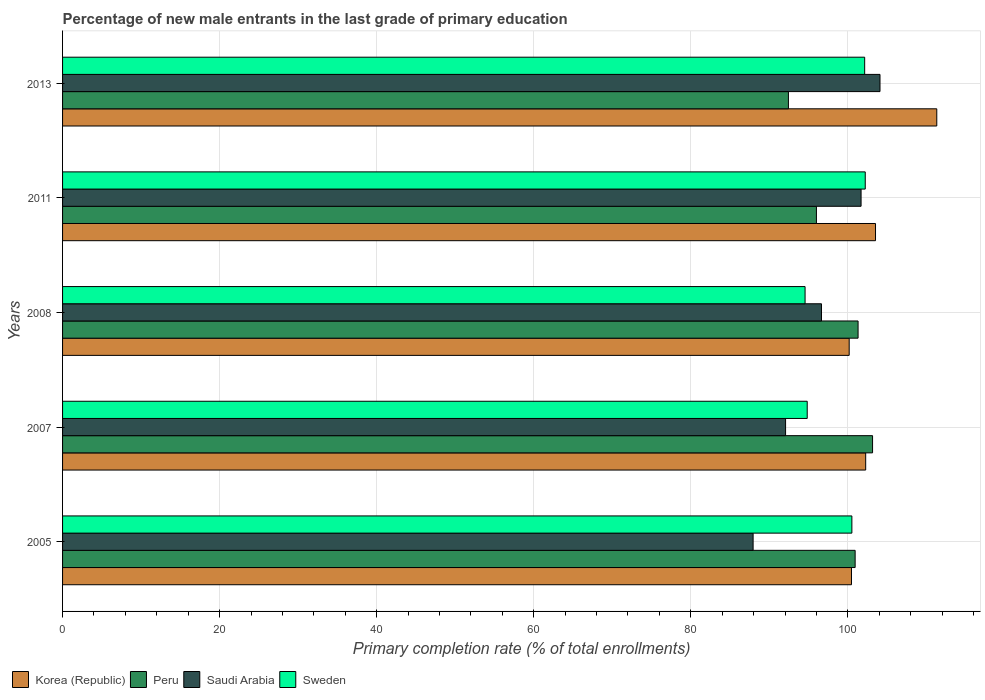How many groups of bars are there?
Provide a short and direct response. 5. Are the number of bars per tick equal to the number of legend labels?
Offer a terse response. Yes. Are the number of bars on each tick of the Y-axis equal?
Offer a terse response. Yes. How many bars are there on the 2nd tick from the bottom?
Offer a very short reply. 4. In how many cases, is the number of bars for a given year not equal to the number of legend labels?
Provide a short and direct response. 0. What is the percentage of new male entrants in Korea (Republic) in 2005?
Offer a very short reply. 100.47. Across all years, what is the maximum percentage of new male entrants in Saudi Arabia?
Provide a short and direct response. 104.1. Across all years, what is the minimum percentage of new male entrants in Korea (Republic)?
Your answer should be very brief. 100.17. In which year was the percentage of new male entrants in Sweden maximum?
Offer a terse response. 2011. What is the total percentage of new male entrants in Peru in the graph?
Ensure brevity in your answer.  493.83. What is the difference between the percentage of new male entrants in Sweden in 2008 and that in 2011?
Your answer should be compact. -7.66. What is the difference between the percentage of new male entrants in Korea (Republic) in 2011 and the percentage of new male entrants in Peru in 2008?
Provide a succinct answer. 2.22. What is the average percentage of new male entrants in Korea (Republic) per year?
Give a very brief answer. 103.55. In the year 2013, what is the difference between the percentage of new male entrants in Sweden and percentage of new male entrants in Korea (Republic)?
Ensure brevity in your answer.  -9.18. What is the ratio of the percentage of new male entrants in Saudi Arabia in 2005 to that in 2008?
Provide a succinct answer. 0.91. Is the percentage of new male entrants in Peru in 2007 less than that in 2013?
Your answer should be very brief. No. Is the difference between the percentage of new male entrants in Sweden in 2007 and 2008 greater than the difference between the percentage of new male entrants in Korea (Republic) in 2007 and 2008?
Keep it short and to the point. No. What is the difference between the highest and the second highest percentage of new male entrants in Saudi Arabia?
Make the answer very short. 2.41. What is the difference between the highest and the lowest percentage of new male entrants in Saudi Arabia?
Provide a succinct answer. 16.16. In how many years, is the percentage of new male entrants in Korea (Republic) greater than the average percentage of new male entrants in Korea (Republic) taken over all years?
Provide a succinct answer. 1. Is it the case that in every year, the sum of the percentage of new male entrants in Sweden and percentage of new male entrants in Saudi Arabia is greater than the sum of percentage of new male entrants in Korea (Republic) and percentage of new male entrants in Peru?
Provide a short and direct response. No. What does the 2nd bar from the top in 2011 represents?
Give a very brief answer. Saudi Arabia. What does the 2nd bar from the bottom in 2013 represents?
Your answer should be very brief. Peru. Is it the case that in every year, the sum of the percentage of new male entrants in Sweden and percentage of new male entrants in Korea (Republic) is greater than the percentage of new male entrants in Saudi Arabia?
Provide a succinct answer. Yes. Are the values on the major ticks of X-axis written in scientific E-notation?
Give a very brief answer. No. Does the graph contain grids?
Offer a terse response. Yes. Where does the legend appear in the graph?
Make the answer very short. Bottom left. How many legend labels are there?
Keep it short and to the point. 4. What is the title of the graph?
Keep it short and to the point. Percentage of new male entrants in the last grade of primary education. What is the label or title of the X-axis?
Give a very brief answer. Primary completion rate (% of total enrollments). What is the Primary completion rate (% of total enrollments) of Korea (Republic) in 2005?
Your response must be concise. 100.47. What is the Primary completion rate (% of total enrollments) in Peru in 2005?
Ensure brevity in your answer.  100.93. What is the Primary completion rate (% of total enrollments) of Saudi Arabia in 2005?
Your response must be concise. 87.94. What is the Primary completion rate (% of total enrollments) of Sweden in 2005?
Provide a short and direct response. 100.52. What is the Primary completion rate (% of total enrollments) in Korea (Republic) in 2007?
Offer a terse response. 102.28. What is the Primary completion rate (% of total enrollments) in Peru in 2007?
Make the answer very short. 103.15. What is the Primary completion rate (% of total enrollments) of Saudi Arabia in 2007?
Give a very brief answer. 92.07. What is the Primary completion rate (% of total enrollments) of Sweden in 2007?
Your answer should be compact. 94.83. What is the Primary completion rate (% of total enrollments) of Korea (Republic) in 2008?
Give a very brief answer. 100.17. What is the Primary completion rate (% of total enrollments) in Peru in 2008?
Your response must be concise. 101.31. What is the Primary completion rate (% of total enrollments) in Saudi Arabia in 2008?
Offer a very short reply. 96.65. What is the Primary completion rate (% of total enrollments) of Sweden in 2008?
Make the answer very short. 94.56. What is the Primary completion rate (% of total enrollments) of Korea (Republic) in 2011?
Your answer should be compact. 103.53. What is the Primary completion rate (% of total enrollments) in Peru in 2011?
Offer a very short reply. 96. What is the Primary completion rate (% of total enrollments) in Saudi Arabia in 2011?
Provide a succinct answer. 101.69. What is the Primary completion rate (% of total enrollments) in Sweden in 2011?
Provide a short and direct response. 102.22. What is the Primary completion rate (% of total enrollments) in Korea (Republic) in 2013?
Your answer should be very brief. 111.33. What is the Primary completion rate (% of total enrollments) of Peru in 2013?
Keep it short and to the point. 92.44. What is the Primary completion rate (% of total enrollments) of Saudi Arabia in 2013?
Your answer should be very brief. 104.1. What is the Primary completion rate (% of total enrollments) in Sweden in 2013?
Your answer should be compact. 102.15. Across all years, what is the maximum Primary completion rate (% of total enrollments) of Korea (Republic)?
Give a very brief answer. 111.33. Across all years, what is the maximum Primary completion rate (% of total enrollments) of Peru?
Provide a succinct answer. 103.15. Across all years, what is the maximum Primary completion rate (% of total enrollments) of Saudi Arabia?
Offer a very short reply. 104.1. Across all years, what is the maximum Primary completion rate (% of total enrollments) of Sweden?
Provide a succinct answer. 102.22. Across all years, what is the minimum Primary completion rate (% of total enrollments) of Korea (Republic)?
Provide a succinct answer. 100.17. Across all years, what is the minimum Primary completion rate (% of total enrollments) of Peru?
Your response must be concise. 92.44. Across all years, what is the minimum Primary completion rate (% of total enrollments) in Saudi Arabia?
Your answer should be very brief. 87.94. Across all years, what is the minimum Primary completion rate (% of total enrollments) of Sweden?
Provide a succinct answer. 94.56. What is the total Primary completion rate (% of total enrollments) of Korea (Republic) in the graph?
Offer a very short reply. 517.77. What is the total Primary completion rate (% of total enrollments) in Peru in the graph?
Offer a terse response. 493.83. What is the total Primary completion rate (% of total enrollments) of Saudi Arabia in the graph?
Your answer should be compact. 482.45. What is the total Primary completion rate (% of total enrollments) of Sweden in the graph?
Give a very brief answer. 494.27. What is the difference between the Primary completion rate (% of total enrollments) in Korea (Republic) in 2005 and that in 2007?
Give a very brief answer. -1.81. What is the difference between the Primary completion rate (% of total enrollments) in Peru in 2005 and that in 2007?
Offer a terse response. -2.22. What is the difference between the Primary completion rate (% of total enrollments) in Saudi Arabia in 2005 and that in 2007?
Offer a terse response. -4.13. What is the difference between the Primary completion rate (% of total enrollments) of Sweden in 2005 and that in 2007?
Your answer should be compact. 5.69. What is the difference between the Primary completion rate (% of total enrollments) of Korea (Republic) in 2005 and that in 2008?
Make the answer very short. 0.29. What is the difference between the Primary completion rate (% of total enrollments) in Peru in 2005 and that in 2008?
Ensure brevity in your answer.  -0.37. What is the difference between the Primary completion rate (% of total enrollments) in Saudi Arabia in 2005 and that in 2008?
Give a very brief answer. -8.71. What is the difference between the Primary completion rate (% of total enrollments) of Sweden in 2005 and that in 2008?
Offer a terse response. 5.96. What is the difference between the Primary completion rate (% of total enrollments) in Korea (Republic) in 2005 and that in 2011?
Offer a terse response. -3.06. What is the difference between the Primary completion rate (% of total enrollments) in Peru in 2005 and that in 2011?
Give a very brief answer. 4.93. What is the difference between the Primary completion rate (% of total enrollments) in Saudi Arabia in 2005 and that in 2011?
Ensure brevity in your answer.  -13.75. What is the difference between the Primary completion rate (% of total enrollments) in Sweden in 2005 and that in 2011?
Provide a short and direct response. -1.7. What is the difference between the Primary completion rate (% of total enrollments) of Korea (Republic) in 2005 and that in 2013?
Your answer should be very brief. -10.86. What is the difference between the Primary completion rate (% of total enrollments) of Peru in 2005 and that in 2013?
Provide a succinct answer. 8.5. What is the difference between the Primary completion rate (% of total enrollments) in Saudi Arabia in 2005 and that in 2013?
Provide a succinct answer. -16.16. What is the difference between the Primary completion rate (% of total enrollments) in Sweden in 2005 and that in 2013?
Offer a very short reply. -1.63. What is the difference between the Primary completion rate (% of total enrollments) in Korea (Republic) in 2007 and that in 2008?
Offer a very short reply. 2.1. What is the difference between the Primary completion rate (% of total enrollments) in Peru in 2007 and that in 2008?
Provide a short and direct response. 1.85. What is the difference between the Primary completion rate (% of total enrollments) of Saudi Arabia in 2007 and that in 2008?
Provide a succinct answer. -4.57. What is the difference between the Primary completion rate (% of total enrollments) in Sweden in 2007 and that in 2008?
Offer a very short reply. 0.27. What is the difference between the Primary completion rate (% of total enrollments) in Korea (Republic) in 2007 and that in 2011?
Give a very brief answer. -1.25. What is the difference between the Primary completion rate (% of total enrollments) of Peru in 2007 and that in 2011?
Offer a terse response. 7.15. What is the difference between the Primary completion rate (% of total enrollments) of Saudi Arabia in 2007 and that in 2011?
Provide a short and direct response. -9.61. What is the difference between the Primary completion rate (% of total enrollments) in Sweden in 2007 and that in 2011?
Provide a short and direct response. -7.39. What is the difference between the Primary completion rate (% of total enrollments) in Korea (Republic) in 2007 and that in 2013?
Your answer should be compact. -9.05. What is the difference between the Primary completion rate (% of total enrollments) of Peru in 2007 and that in 2013?
Your response must be concise. 10.72. What is the difference between the Primary completion rate (% of total enrollments) of Saudi Arabia in 2007 and that in 2013?
Provide a succinct answer. -12.03. What is the difference between the Primary completion rate (% of total enrollments) of Sweden in 2007 and that in 2013?
Offer a very short reply. -7.32. What is the difference between the Primary completion rate (% of total enrollments) of Korea (Republic) in 2008 and that in 2011?
Your response must be concise. -3.35. What is the difference between the Primary completion rate (% of total enrollments) in Peru in 2008 and that in 2011?
Provide a succinct answer. 5.3. What is the difference between the Primary completion rate (% of total enrollments) of Saudi Arabia in 2008 and that in 2011?
Offer a terse response. -5.04. What is the difference between the Primary completion rate (% of total enrollments) in Sweden in 2008 and that in 2011?
Your answer should be compact. -7.66. What is the difference between the Primary completion rate (% of total enrollments) in Korea (Republic) in 2008 and that in 2013?
Offer a terse response. -11.16. What is the difference between the Primary completion rate (% of total enrollments) in Peru in 2008 and that in 2013?
Your answer should be compact. 8.87. What is the difference between the Primary completion rate (% of total enrollments) in Saudi Arabia in 2008 and that in 2013?
Provide a short and direct response. -7.45. What is the difference between the Primary completion rate (% of total enrollments) in Sweden in 2008 and that in 2013?
Offer a terse response. -7.59. What is the difference between the Primary completion rate (% of total enrollments) in Korea (Republic) in 2011 and that in 2013?
Offer a terse response. -7.8. What is the difference between the Primary completion rate (% of total enrollments) of Peru in 2011 and that in 2013?
Make the answer very short. 3.57. What is the difference between the Primary completion rate (% of total enrollments) in Saudi Arabia in 2011 and that in 2013?
Your answer should be compact. -2.41. What is the difference between the Primary completion rate (% of total enrollments) of Sweden in 2011 and that in 2013?
Give a very brief answer. 0.07. What is the difference between the Primary completion rate (% of total enrollments) in Korea (Republic) in 2005 and the Primary completion rate (% of total enrollments) in Peru in 2007?
Keep it short and to the point. -2.68. What is the difference between the Primary completion rate (% of total enrollments) in Korea (Republic) in 2005 and the Primary completion rate (% of total enrollments) in Saudi Arabia in 2007?
Your response must be concise. 8.39. What is the difference between the Primary completion rate (% of total enrollments) in Korea (Republic) in 2005 and the Primary completion rate (% of total enrollments) in Sweden in 2007?
Offer a terse response. 5.64. What is the difference between the Primary completion rate (% of total enrollments) of Peru in 2005 and the Primary completion rate (% of total enrollments) of Saudi Arabia in 2007?
Give a very brief answer. 8.86. What is the difference between the Primary completion rate (% of total enrollments) of Peru in 2005 and the Primary completion rate (% of total enrollments) of Sweden in 2007?
Your response must be concise. 6.1. What is the difference between the Primary completion rate (% of total enrollments) in Saudi Arabia in 2005 and the Primary completion rate (% of total enrollments) in Sweden in 2007?
Provide a short and direct response. -6.89. What is the difference between the Primary completion rate (% of total enrollments) in Korea (Republic) in 2005 and the Primary completion rate (% of total enrollments) in Peru in 2008?
Provide a succinct answer. -0.84. What is the difference between the Primary completion rate (% of total enrollments) in Korea (Republic) in 2005 and the Primary completion rate (% of total enrollments) in Saudi Arabia in 2008?
Your response must be concise. 3.82. What is the difference between the Primary completion rate (% of total enrollments) of Korea (Republic) in 2005 and the Primary completion rate (% of total enrollments) of Sweden in 2008?
Your response must be concise. 5.91. What is the difference between the Primary completion rate (% of total enrollments) in Peru in 2005 and the Primary completion rate (% of total enrollments) in Saudi Arabia in 2008?
Provide a short and direct response. 4.29. What is the difference between the Primary completion rate (% of total enrollments) in Peru in 2005 and the Primary completion rate (% of total enrollments) in Sweden in 2008?
Your response must be concise. 6.38. What is the difference between the Primary completion rate (% of total enrollments) of Saudi Arabia in 2005 and the Primary completion rate (% of total enrollments) of Sweden in 2008?
Your answer should be very brief. -6.62. What is the difference between the Primary completion rate (% of total enrollments) of Korea (Republic) in 2005 and the Primary completion rate (% of total enrollments) of Peru in 2011?
Give a very brief answer. 4.47. What is the difference between the Primary completion rate (% of total enrollments) of Korea (Republic) in 2005 and the Primary completion rate (% of total enrollments) of Saudi Arabia in 2011?
Your answer should be compact. -1.22. What is the difference between the Primary completion rate (% of total enrollments) in Korea (Republic) in 2005 and the Primary completion rate (% of total enrollments) in Sweden in 2011?
Keep it short and to the point. -1.75. What is the difference between the Primary completion rate (% of total enrollments) of Peru in 2005 and the Primary completion rate (% of total enrollments) of Saudi Arabia in 2011?
Your response must be concise. -0.75. What is the difference between the Primary completion rate (% of total enrollments) of Peru in 2005 and the Primary completion rate (% of total enrollments) of Sweden in 2011?
Keep it short and to the point. -1.29. What is the difference between the Primary completion rate (% of total enrollments) in Saudi Arabia in 2005 and the Primary completion rate (% of total enrollments) in Sweden in 2011?
Keep it short and to the point. -14.28. What is the difference between the Primary completion rate (% of total enrollments) in Korea (Republic) in 2005 and the Primary completion rate (% of total enrollments) in Peru in 2013?
Ensure brevity in your answer.  8.03. What is the difference between the Primary completion rate (% of total enrollments) of Korea (Republic) in 2005 and the Primary completion rate (% of total enrollments) of Saudi Arabia in 2013?
Keep it short and to the point. -3.63. What is the difference between the Primary completion rate (% of total enrollments) of Korea (Republic) in 2005 and the Primary completion rate (% of total enrollments) of Sweden in 2013?
Your answer should be compact. -1.68. What is the difference between the Primary completion rate (% of total enrollments) in Peru in 2005 and the Primary completion rate (% of total enrollments) in Saudi Arabia in 2013?
Make the answer very short. -3.17. What is the difference between the Primary completion rate (% of total enrollments) in Peru in 2005 and the Primary completion rate (% of total enrollments) in Sweden in 2013?
Give a very brief answer. -1.21. What is the difference between the Primary completion rate (% of total enrollments) in Saudi Arabia in 2005 and the Primary completion rate (% of total enrollments) in Sweden in 2013?
Offer a very short reply. -14.21. What is the difference between the Primary completion rate (% of total enrollments) in Korea (Republic) in 2007 and the Primary completion rate (% of total enrollments) in Peru in 2008?
Your answer should be very brief. 0.97. What is the difference between the Primary completion rate (% of total enrollments) in Korea (Republic) in 2007 and the Primary completion rate (% of total enrollments) in Saudi Arabia in 2008?
Provide a succinct answer. 5.63. What is the difference between the Primary completion rate (% of total enrollments) in Korea (Republic) in 2007 and the Primary completion rate (% of total enrollments) in Sweden in 2008?
Provide a short and direct response. 7.72. What is the difference between the Primary completion rate (% of total enrollments) in Peru in 2007 and the Primary completion rate (% of total enrollments) in Saudi Arabia in 2008?
Give a very brief answer. 6.51. What is the difference between the Primary completion rate (% of total enrollments) of Peru in 2007 and the Primary completion rate (% of total enrollments) of Sweden in 2008?
Ensure brevity in your answer.  8.6. What is the difference between the Primary completion rate (% of total enrollments) in Saudi Arabia in 2007 and the Primary completion rate (% of total enrollments) in Sweden in 2008?
Your answer should be very brief. -2.48. What is the difference between the Primary completion rate (% of total enrollments) of Korea (Republic) in 2007 and the Primary completion rate (% of total enrollments) of Peru in 2011?
Give a very brief answer. 6.27. What is the difference between the Primary completion rate (% of total enrollments) of Korea (Republic) in 2007 and the Primary completion rate (% of total enrollments) of Saudi Arabia in 2011?
Give a very brief answer. 0.59. What is the difference between the Primary completion rate (% of total enrollments) of Korea (Republic) in 2007 and the Primary completion rate (% of total enrollments) of Sweden in 2011?
Give a very brief answer. 0.06. What is the difference between the Primary completion rate (% of total enrollments) of Peru in 2007 and the Primary completion rate (% of total enrollments) of Saudi Arabia in 2011?
Provide a short and direct response. 1.46. What is the difference between the Primary completion rate (% of total enrollments) in Peru in 2007 and the Primary completion rate (% of total enrollments) in Sweden in 2011?
Keep it short and to the point. 0.93. What is the difference between the Primary completion rate (% of total enrollments) in Saudi Arabia in 2007 and the Primary completion rate (% of total enrollments) in Sweden in 2011?
Keep it short and to the point. -10.15. What is the difference between the Primary completion rate (% of total enrollments) in Korea (Republic) in 2007 and the Primary completion rate (% of total enrollments) in Peru in 2013?
Give a very brief answer. 9.84. What is the difference between the Primary completion rate (% of total enrollments) in Korea (Republic) in 2007 and the Primary completion rate (% of total enrollments) in Saudi Arabia in 2013?
Offer a terse response. -1.82. What is the difference between the Primary completion rate (% of total enrollments) of Korea (Republic) in 2007 and the Primary completion rate (% of total enrollments) of Sweden in 2013?
Keep it short and to the point. 0.13. What is the difference between the Primary completion rate (% of total enrollments) in Peru in 2007 and the Primary completion rate (% of total enrollments) in Saudi Arabia in 2013?
Keep it short and to the point. -0.95. What is the difference between the Primary completion rate (% of total enrollments) of Saudi Arabia in 2007 and the Primary completion rate (% of total enrollments) of Sweden in 2013?
Your answer should be very brief. -10.07. What is the difference between the Primary completion rate (% of total enrollments) of Korea (Republic) in 2008 and the Primary completion rate (% of total enrollments) of Peru in 2011?
Offer a terse response. 4.17. What is the difference between the Primary completion rate (% of total enrollments) in Korea (Republic) in 2008 and the Primary completion rate (% of total enrollments) in Saudi Arabia in 2011?
Make the answer very short. -1.51. What is the difference between the Primary completion rate (% of total enrollments) of Korea (Republic) in 2008 and the Primary completion rate (% of total enrollments) of Sweden in 2011?
Provide a short and direct response. -2.05. What is the difference between the Primary completion rate (% of total enrollments) of Peru in 2008 and the Primary completion rate (% of total enrollments) of Saudi Arabia in 2011?
Provide a short and direct response. -0.38. What is the difference between the Primary completion rate (% of total enrollments) in Peru in 2008 and the Primary completion rate (% of total enrollments) in Sweden in 2011?
Offer a terse response. -0.91. What is the difference between the Primary completion rate (% of total enrollments) in Saudi Arabia in 2008 and the Primary completion rate (% of total enrollments) in Sweden in 2011?
Ensure brevity in your answer.  -5.57. What is the difference between the Primary completion rate (% of total enrollments) in Korea (Republic) in 2008 and the Primary completion rate (% of total enrollments) in Peru in 2013?
Provide a succinct answer. 7.74. What is the difference between the Primary completion rate (% of total enrollments) in Korea (Republic) in 2008 and the Primary completion rate (% of total enrollments) in Saudi Arabia in 2013?
Your answer should be compact. -3.93. What is the difference between the Primary completion rate (% of total enrollments) of Korea (Republic) in 2008 and the Primary completion rate (% of total enrollments) of Sweden in 2013?
Offer a terse response. -1.97. What is the difference between the Primary completion rate (% of total enrollments) of Peru in 2008 and the Primary completion rate (% of total enrollments) of Saudi Arabia in 2013?
Keep it short and to the point. -2.79. What is the difference between the Primary completion rate (% of total enrollments) in Peru in 2008 and the Primary completion rate (% of total enrollments) in Sweden in 2013?
Provide a succinct answer. -0.84. What is the difference between the Primary completion rate (% of total enrollments) in Saudi Arabia in 2008 and the Primary completion rate (% of total enrollments) in Sweden in 2013?
Provide a succinct answer. -5.5. What is the difference between the Primary completion rate (% of total enrollments) of Korea (Republic) in 2011 and the Primary completion rate (% of total enrollments) of Peru in 2013?
Your answer should be very brief. 11.09. What is the difference between the Primary completion rate (% of total enrollments) in Korea (Republic) in 2011 and the Primary completion rate (% of total enrollments) in Saudi Arabia in 2013?
Provide a succinct answer. -0.57. What is the difference between the Primary completion rate (% of total enrollments) of Korea (Republic) in 2011 and the Primary completion rate (% of total enrollments) of Sweden in 2013?
Your response must be concise. 1.38. What is the difference between the Primary completion rate (% of total enrollments) of Peru in 2011 and the Primary completion rate (% of total enrollments) of Saudi Arabia in 2013?
Provide a succinct answer. -8.1. What is the difference between the Primary completion rate (% of total enrollments) of Peru in 2011 and the Primary completion rate (% of total enrollments) of Sweden in 2013?
Your answer should be compact. -6.14. What is the difference between the Primary completion rate (% of total enrollments) of Saudi Arabia in 2011 and the Primary completion rate (% of total enrollments) of Sweden in 2013?
Your answer should be compact. -0.46. What is the average Primary completion rate (% of total enrollments) in Korea (Republic) per year?
Make the answer very short. 103.55. What is the average Primary completion rate (% of total enrollments) of Peru per year?
Your answer should be very brief. 98.77. What is the average Primary completion rate (% of total enrollments) of Saudi Arabia per year?
Your answer should be compact. 96.49. What is the average Primary completion rate (% of total enrollments) in Sweden per year?
Your response must be concise. 98.85. In the year 2005, what is the difference between the Primary completion rate (% of total enrollments) in Korea (Republic) and Primary completion rate (% of total enrollments) in Peru?
Make the answer very short. -0.47. In the year 2005, what is the difference between the Primary completion rate (% of total enrollments) in Korea (Republic) and Primary completion rate (% of total enrollments) in Saudi Arabia?
Make the answer very short. 12.53. In the year 2005, what is the difference between the Primary completion rate (% of total enrollments) in Korea (Republic) and Primary completion rate (% of total enrollments) in Sweden?
Your answer should be compact. -0.05. In the year 2005, what is the difference between the Primary completion rate (% of total enrollments) of Peru and Primary completion rate (% of total enrollments) of Saudi Arabia?
Provide a short and direct response. 12.99. In the year 2005, what is the difference between the Primary completion rate (% of total enrollments) in Peru and Primary completion rate (% of total enrollments) in Sweden?
Provide a short and direct response. 0.42. In the year 2005, what is the difference between the Primary completion rate (% of total enrollments) in Saudi Arabia and Primary completion rate (% of total enrollments) in Sweden?
Offer a very short reply. -12.58. In the year 2007, what is the difference between the Primary completion rate (% of total enrollments) of Korea (Republic) and Primary completion rate (% of total enrollments) of Peru?
Offer a very short reply. -0.88. In the year 2007, what is the difference between the Primary completion rate (% of total enrollments) in Korea (Republic) and Primary completion rate (% of total enrollments) in Saudi Arabia?
Your answer should be very brief. 10.2. In the year 2007, what is the difference between the Primary completion rate (% of total enrollments) in Korea (Republic) and Primary completion rate (% of total enrollments) in Sweden?
Offer a terse response. 7.45. In the year 2007, what is the difference between the Primary completion rate (% of total enrollments) in Peru and Primary completion rate (% of total enrollments) in Saudi Arabia?
Keep it short and to the point. 11.08. In the year 2007, what is the difference between the Primary completion rate (% of total enrollments) of Peru and Primary completion rate (% of total enrollments) of Sweden?
Keep it short and to the point. 8.32. In the year 2007, what is the difference between the Primary completion rate (% of total enrollments) in Saudi Arabia and Primary completion rate (% of total enrollments) in Sweden?
Your response must be concise. -2.76. In the year 2008, what is the difference between the Primary completion rate (% of total enrollments) of Korea (Republic) and Primary completion rate (% of total enrollments) of Peru?
Keep it short and to the point. -1.13. In the year 2008, what is the difference between the Primary completion rate (% of total enrollments) in Korea (Republic) and Primary completion rate (% of total enrollments) in Saudi Arabia?
Make the answer very short. 3.53. In the year 2008, what is the difference between the Primary completion rate (% of total enrollments) of Korea (Republic) and Primary completion rate (% of total enrollments) of Sweden?
Provide a short and direct response. 5.62. In the year 2008, what is the difference between the Primary completion rate (% of total enrollments) in Peru and Primary completion rate (% of total enrollments) in Saudi Arabia?
Provide a succinct answer. 4.66. In the year 2008, what is the difference between the Primary completion rate (% of total enrollments) in Peru and Primary completion rate (% of total enrollments) in Sweden?
Provide a succinct answer. 6.75. In the year 2008, what is the difference between the Primary completion rate (% of total enrollments) in Saudi Arabia and Primary completion rate (% of total enrollments) in Sweden?
Make the answer very short. 2.09. In the year 2011, what is the difference between the Primary completion rate (% of total enrollments) in Korea (Republic) and Primary completion rate (% of total enrollments) in Peru?
Offer a very short reply. 7.53. In the year 2011, what is the difference between the Primary completion rate (% of total enrollments) in Korea (Republic) and Primary completion rate (% of total enrollments) in Saudi Arabia?
Offer a very short reply. 1.84. In the year 2011, what is the difference between the Primary completion rate (% of total enrollments) in Korea (Republic) and Primary completion rate (% of total enrollments) in Sweden?
Give a very brief answer. 1.31. In the year 2011, what is the difference between the Primary completion rate (% of total enrollments) of Peru and Primary completion rate (% of total enrollments) of Saudi Arabia?
Keep it short and to the point. -5.69. In the year 2011, what is the difference between the Primary completion rate (% of total enrollments) in Peru and Primary completion rate (% of total enrollments) in Sweden?
Ensure brevity in your answer.  -6.22. In the year 2011, what is the difference between the Primary completion rate (% of total enrollments) in Saudi Arabia and Primary completion rate (% of total enrollments) in Sweden?
Provide a succinct answer. -0.53. In the year 2013, what is the difference between the Primary completion rate (% of total enrollments) in Korea (Republic) and Primary completion rate (% of total enrollments) in Peru?
Offer a very short reply. 18.89. In the year 2013, what is the difference between the Primary completion rate (% of total enrollments) of Korea (Republic) and Primary completion rate (% of total enrollments) of Saudi Arabia?
Offer a very short reply. 7.23. In the year 2013, what is the difference between the Primary completion rate (% of total enrollments) in Korea (Republic) and Primary completion rate (% of total enrollments) in Sweden?
Ensure brevity in your answer.  9.18. In the year 2013, what is the difference between the Primary completion rate (% of total enrollments) in Peru and Primary completion rate (% of total enrollments) in Saudi Arabia?
Your response must be concise. -11.66. In the year 2013, what is the difference between the Primary completion rate (% of total enrollments) of Peru and Primary completion rate (% of total enrollments) of Sweden?
Your answer should be very brief. -9.71. In the year 2013, what is the difference between the Primary completion rate (% of total enrollments) of Saudi Arabia and Primary completion rate (% of total enrollments) of Sweden?
Offer a very short reply. 1.95. What is the ratio of the Primary completion rate (% of total enrollments) of Korea (Republic) in 2005 to that in 2007?
Your answer should be very brief. 0.98. What is the ratio of the Primary completion rate (% of total enrollments) of Peru in 2005 to that in 2007?
Give a very brief answer. 0.98. What is the ratio of the Primary completion rate (% of total enrollments) in Saudi Arabia in 2005 to that in 2007?
Your answer should be compact. 0.96. What is the ratio of the Primary completion rate (% of total enrollments) in Sweden in 2005 to that in 2007?
Offer a terse response. 1.06. What is the ratio of the Primary completion rate (% of total enrollments) of Peru in 2005 to that in 2008?
Give a very brief answer. 1. What is the ratio of the Primary completion rate (% of total enrollments) in Saudi Arabia in 2005 to that in 2008?
Give a very brief answer. 0.91. What is the ratio of the Primary completion rate (% of total enrollments) in Sweden in 2005 to that in 2008?
Offer a terse response. 1.06. What is the ratio of the Primary completion rate (% of total enrollments) of Korea (Republic) in 2005 to that in 2011?
Give a very brief answer. 0.97. What is the ratio of the Primary completion rate (% of total enrollments) of Peru in 2005 to that in 2011?
Keep it short and to the point. 1.05. What is the ratio of the Primary completion rate (% of total enrollments) in Saudi Arabia in 2005 to that in 2011?
Provide a succinct answer. 0.86. What is the ratio of the Primary completion rate (% of total enrollments) in Sweden in 2005 to that in 2011?
Give a very brief answer. 0.98. What is the ratio of the Primary completion rate (% of total enrollments) of Korea (Republic) in 2005 to that in 2013?
Provide a succinct answer. 0.9. What is the ratio of the Primary completion rate (% of total enrollments) in Peru in 2005 to that in 2013?
Offer a very short reply. 1.09. What is the ratio of the Primary completion rate (% of total enrollments) of Saudi Arabia in 2005 to that in 2013?
Keep it short and to the point. 0.84. What is the ratio of the Primary completion rate (% of total enrollments) of Korea (Republic) in 2007 to that in 2008?
Keep it short and to the point. 1.02. What is the ratio of the Primary completion rate (% of total enrollments) of Peru in 2007 to that in 2008?
Give a very brief answer. 1.02. What is the ratio of the Primary completion rate (% of total enrollments) in Saudi Arabia in 2007 to that in 2008?
Ensure brevity in your answer.  0.95. What is the ratio of the Primary completion rate (% of total enrollments) in Korea (Republic) in 2007 to that in 2011?
Your answer should be compact. 0.99. What is the ratio of the Primary completion rate (% of total enrollments) of Peru in 2007 to that in 2011?
Keep it short and to the point. 1.07. What is the ratio of the Primary completion rate (% of total enrollments) in Saudi Arabia in 2007 to that in 2011?
Your answer should be compact. 0.91. What is the ratio of the Primary completion rate (% of total enrollments) in Sweden in 2007 to that in 2011?
Keep it short and to the point. 0.93. What is the ratio of the Primary completion rate (% of total enrollments) of Korea (Republic) in 2007 to that in 2013?
Your response must be concise. 0.92. What is the ratio of the Primary completion rate (% of total enrollments) of Peru in 2007 to that in 2013?
Your answer should be very brief. 1.12. What is the ratio of the Primary completion rate (% of total enrollments) of Saudi Arabia in 2007 to that in 2013?
Ensure brevity in your answer.  0.88. What is the ratio of the Primary completion rate (% of total enrollments) in Sweden in 2007 to that in 2013?
Keep it short and to the point. 0.93. What is the ratio of the Primary completion rate (% of total enrollments) in Korea (Republic) in 2008 to that in 2011?
Make the answer very short. 0.97. What is the ratio of the Primary completion rate (% of total enrollments) in Peru in 2008 to that in 2011?
Your response must be concise. 1.06. What is the ratio of the Primary completion rate (% of total enrollments) of Saudi Arabia in 2008 to that in 2011?
Make the answer very short. 0.95. What is the ratio of the Primary completion rate (% of total enrollments) in Sweden in 2008 to that in 2011?
Make the answer very short. 0.93. What is the ratio of the Primary completion rate (% of total enrollments) in Korea (Republic) in 2008 to that in 2013?
Offer a very short reply. 0.9. What is the ratio of the Primary completion rate (% of total enrollments) of Peru in 2008 to that in 2013?
Offer a terse response. 1.1. What is the ratio of the Primary completion rate (% of total enrollments) of Saudi Arabia in 2008 to that in 2013?
Provide a short and direct response. 0.93. What is the ratio of the Primary completion rate (% of total enrollments) of Sweden in 2008 to that in 2013?
Your answer should be compact. 0.93. What is the ratio of the Primary completion rate (% of total enrollments) of Korea (Republic) in 2011 to that in 2013?
Keep it short and to the point. 0.93. What is the ratio of the Primary completion rate (% of total enrollments) in Peru in 2011 to that in 2013?
Your answer should be compact. 1.04. What is the ratio of the Primary completion rate (% of total enrollments) in Saudi Arabia in 2011 to that in 2013?
Give a very brief answer. 0.98. What is the difference between the highest and the second highest Primary completion rate (% of total enrollments) in Korea (Republic)?
Your answer should be very brief. 7.8. What is the difference between the highest and the second highest Primary completion rate (% of total enrollments) in Peru?
Your answer should be compact. 1.85. What is the difference between the highest and the second highest Primary completion rate (% of total enrollments) in Saudi Arabia?
Ensure brevity in your answer.  2.41. What is the difference between the highest and the second highest Primary completion rate (% of total enrollments) of Sweden?
Your response must be concise. 0.07. What is the difference between the highest and the lowest Primary completion rate (% of total enrollments) of Korea (Republic)?
Offer a very short reply. 11.16. What is the difference between the highest and the lowest Primary completion rate (% of total enrollments) of Peru?
Your answer should be very brief. 10.72. What is the difference between the highest and the lowest Primary completion rate (% of total enrollments) in Saudi Arabia?
Your answer should be very brief. 16.16. What is the difference between the highest and the lowest Primary completion rate (% of total enrollments) of Sweden?
Provide a short and direct response. 7.66. 